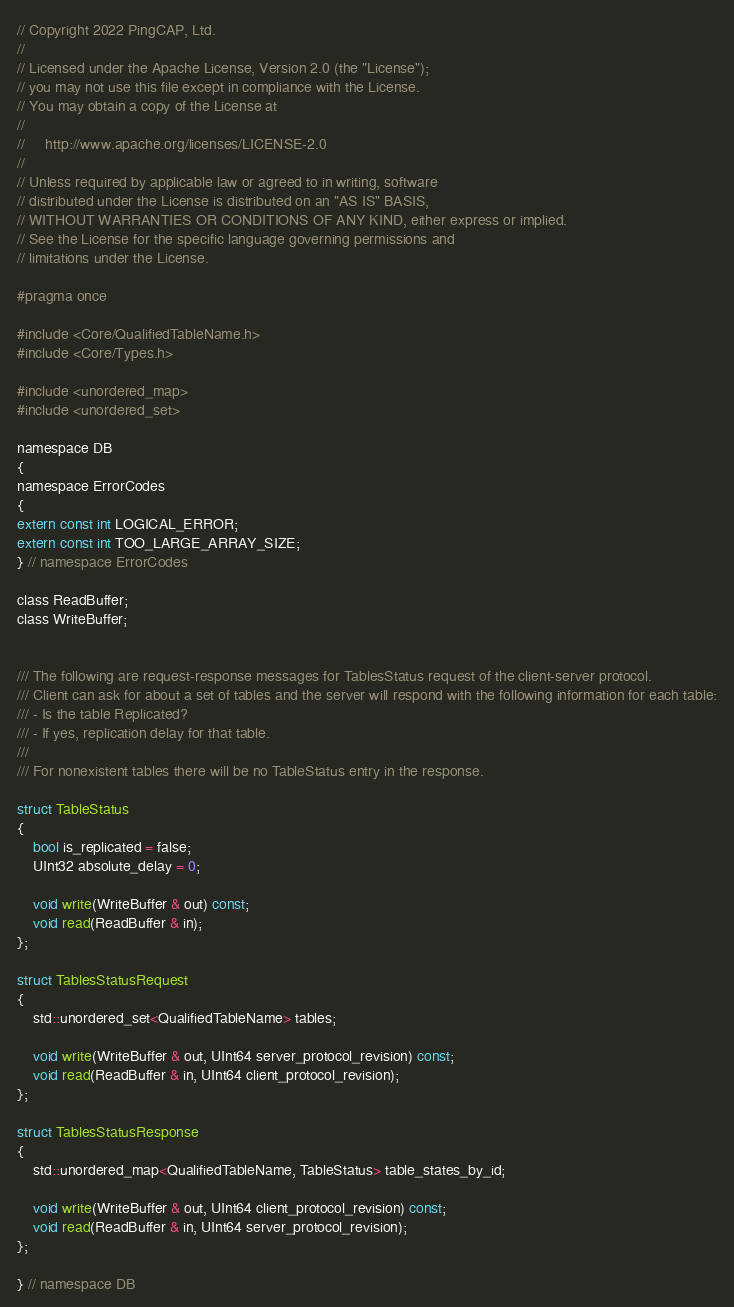<code> <loc_0><loc_0><loc_500><loc_500><_C_>// Copyright 2022 PingCAP, Ltd.
//
// Licensed under the Apache License, Version 2.0 (the "License");
// you may not use this file except in compliance with the License.
// You may obtain a copy of the License at
//
//     http://www.apache.org/licenses/LICENSE-2.0
//
// Unless required by applicable law or agreed to in writing, software
// distributed under the License is distributed on an "AS IS" BASIS,
// WITHOUT WARRANTIES OR CONDITIONS OF ANY KIND, either express or implied.
// See the License for the specific language governing permissions and
// limitations under the License.

#pragma once

#include <Core/QualifiedTableName.h>
#include <Core/Types.h>

#include <unordered_map>
#include <unordered_set>

namespace DB
{
namespace ErrorCodes
{
extern const int LOGICAL_ERROR;
extern const int TOO_LARGE_ARRAY_SIZE;
} // namespace ErrorCodes

class ReadBuffer;
class WriteBuffer;


/// The following are request-response messages for TablesStatus request of the client-server protocol.
/// Client can ask for about a set of tables and the server will respond with the following information for each table:
/// - Is the table Replicated?
/// - If yes, replication delay for that table.
///
/// For nonexistent tables there will be no TableStatus entry in the response.

struct TableStatus
{
    bool is_replicated = false;
    UInt32 absolute_delay = 0;

    void write(WriteBuffer & out) const;
    void read(ReadBuffer & in);
};

struct TablesStatusRequest
{
    std::unordered_set<QualifiedTableName> tables;

    void write(WriteBuffer & out, UInt64 server_protocol_revision) const;
    void read(ReadBuffer & in, UInt64 client_protocol_revision);
};

struct TablesStatusResponse
{
    std::unordered_map<QualifiedTableName, TableStatus> table_states_by_id;

    void write(WriteBuffer & out, UInt64 client_protocol_revision) const;
    void read(ReadBuffer & in, UInt64 server_protocol_revision);
};

} // namespace DB
</code> 